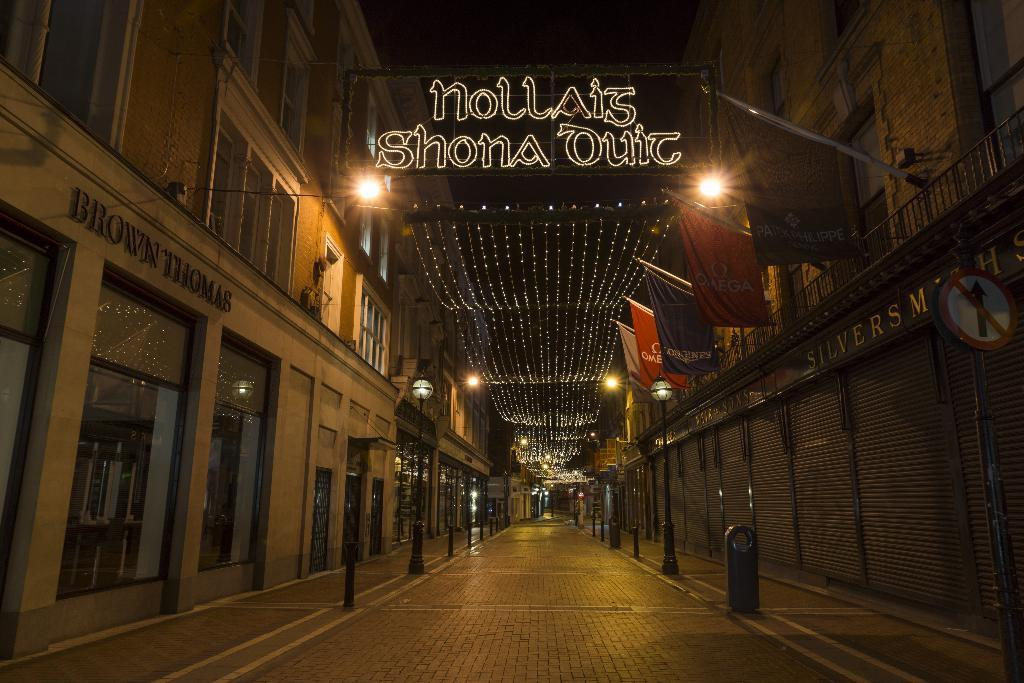Where was the image taken? The image was taken in a street. What is the main feature of the street in the image? There is a road in the middle of the image. What can be seen on both sides of the road? Buildings are present on either side of the road. What is hanging in the middle of the road? Lights are hanging in the middle of the road. Can you see any corn growing on the side of the road in the image? There is no corn visible in the image. What type of air is present in the image? The image does not depict a specific type of air; it simply shows the outdoor environment. 